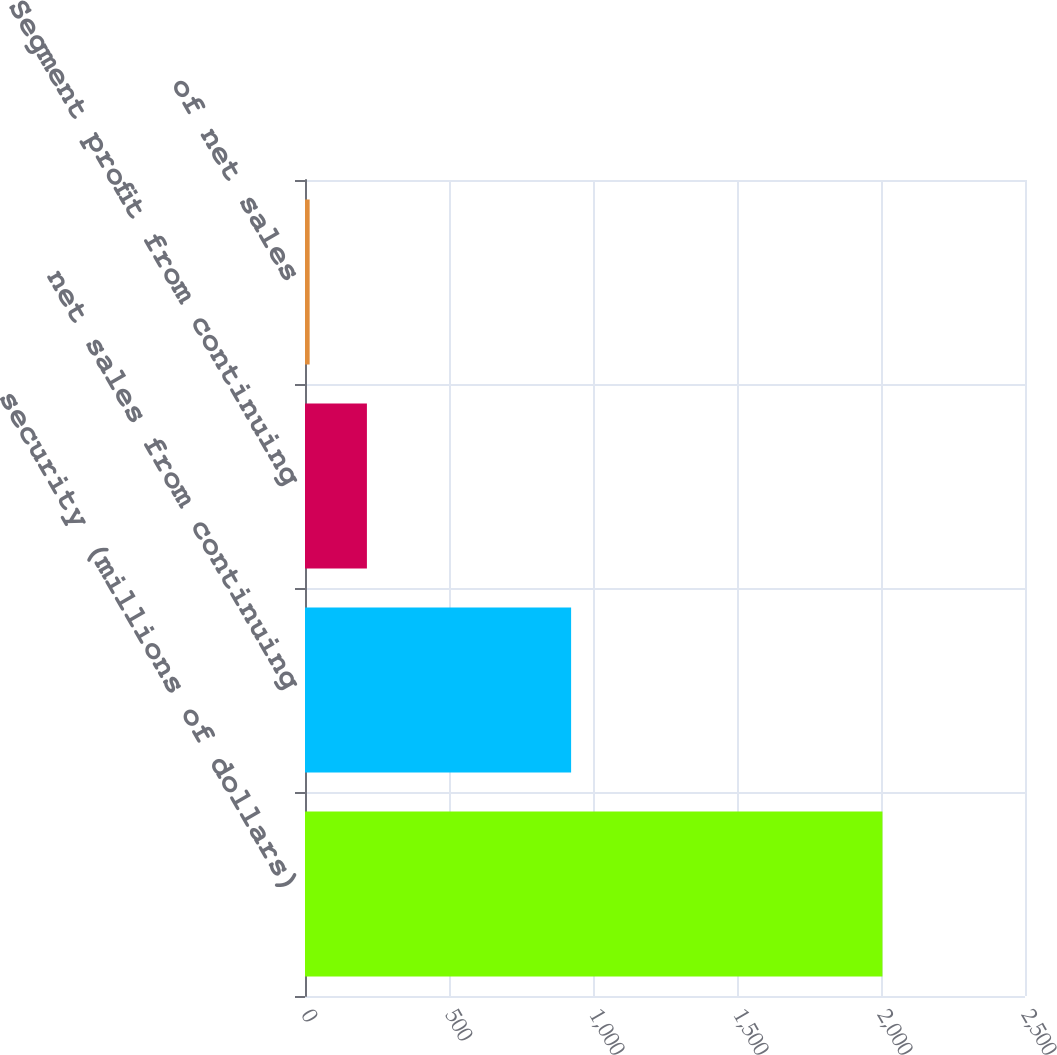Convert chart to OTSL. <chart><loc_0><loc_0><loc_500><loc_500><bar_chart><fcel>security (millions of dollars)<fcel>net sales from continuing<fcel>Segment profit from continuing<fcel>of net sales<nl><fcel>2005<fcel>924<fcel>214.99<fcel>16.1<nl></chart> 